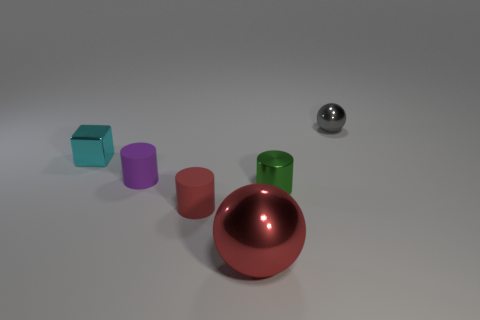Subtract all gray spheres. Subtract all blue blocks. How many spheres are left? 1 Subtract all brown blocks. How many green cylinders are left? 1 Add 2 large purples. How many tiny grays exist? 0 Subtract all small shiny things. Subtract all small matte cylinders. How many objects are left? 1 Add 6 big metallic things. How many big metallic things are left? 7 Add 1 tiny cyan metallic objects. How many tiny cyan metallic objects exist? 2 Add 3 tiny cyan metal things. How many objects exist? 9 Subtract all purple cylinders. How many cylinders are left? 2 Subtract all matte cylinders. How many cylinders are left? 1 Subtract 0 green balls. How many objects are left? 6 